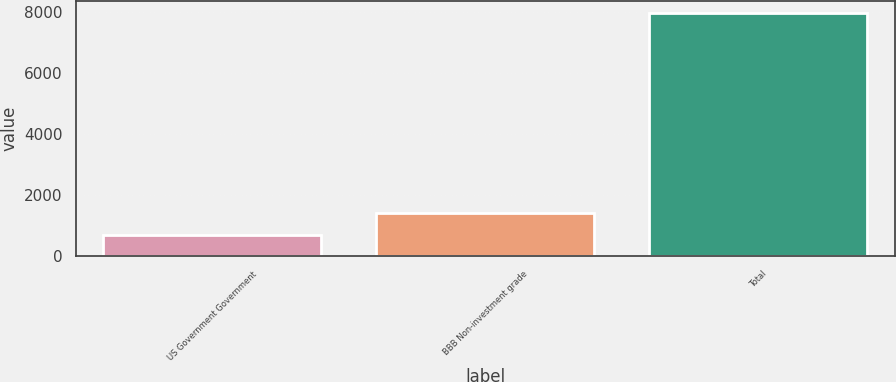Convert chart to OTSL. <chart><loc_0><loc_0><loc_500><loc_500><bar_chart><fcel>US Government Government<fcel>BBB Non-investment grade<fcel>Total<nl><fcel>684<fcel>1410.6<fcel>7950<nl></chart> 